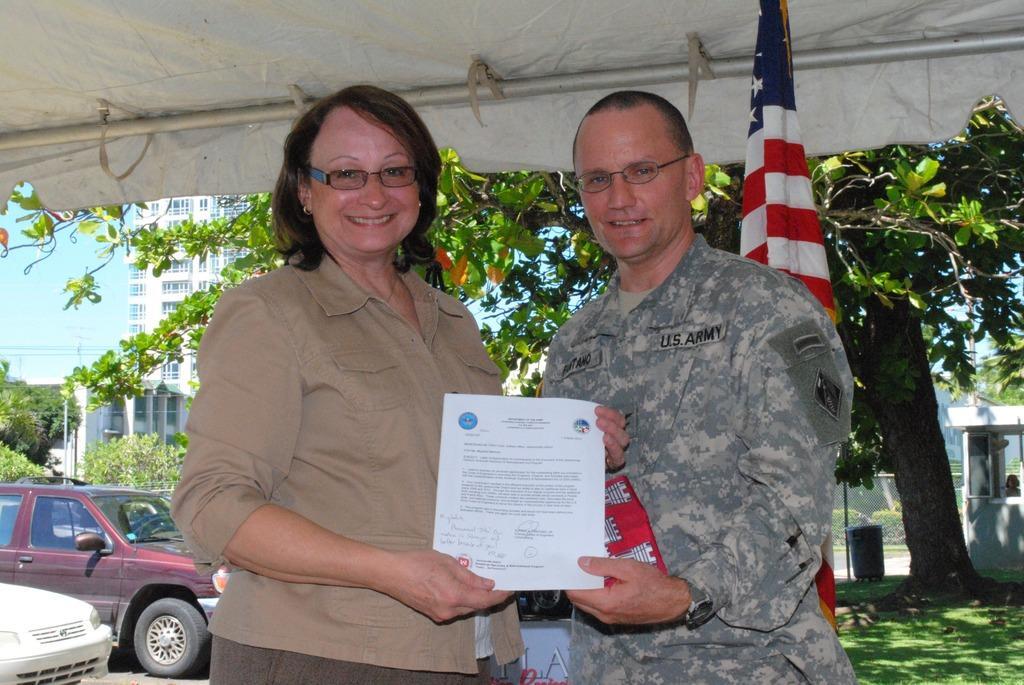Can you describe this image briefly? In this image on the right, there is a man, he wears a shirt, watch, he is holding a paper. On the left there is a woman, she wears a shirt, trouser, she is holding a paper, she is smiling. In the background there are vehicles, trees, flags, buildings, people, dustbin, grass, cables, sky. At the top there is a tent. 